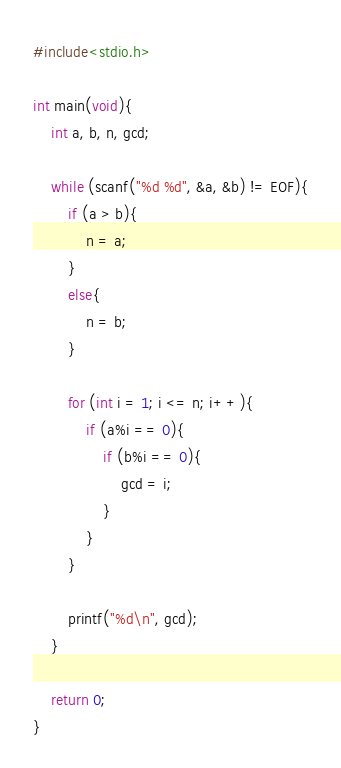Convert code to text. <code><loc_0><loc_0><loc_500><loc_500><_C_>#include<stdio.h>

int main(void){
	int a, b, n, gcd;

	while (scanf("%d %d", &a, &b) != EOF){
		if (a > b){
			n = a;
		}
		else{
			n = b;
		}

		for (int i = 1; i <= n; i++){
			if (a%i == 0){
				if (b%i == 0){
					gcd = i;
				}
			}
		}
		
		printf("%d\n", gcd);
	}

	return 0;
}</code> 